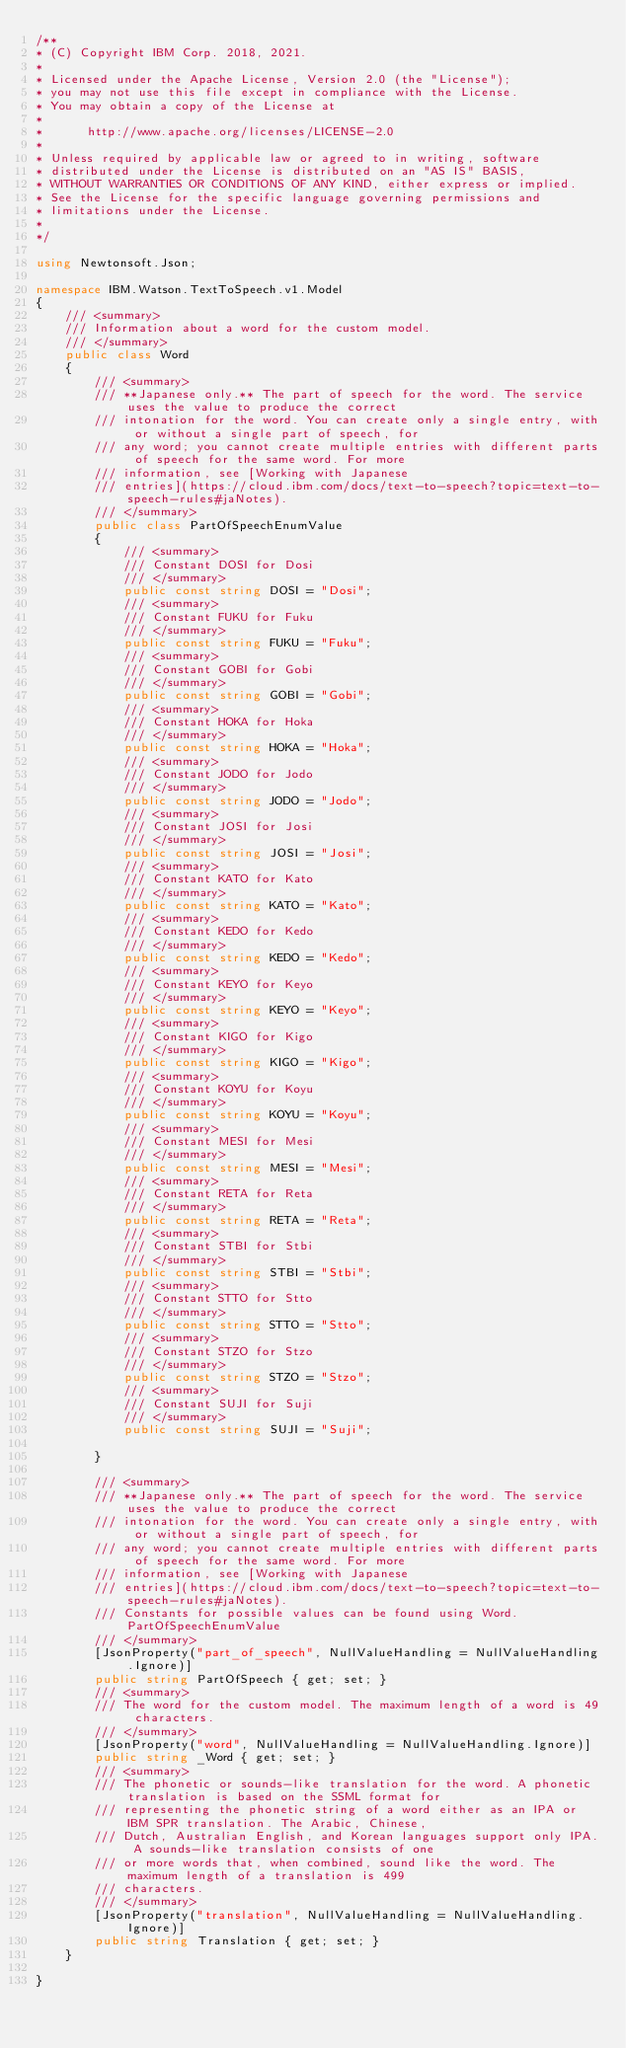<code> <loc_0><loc_0><loc_500><loc_500><_C#_>/**
* (C) Copyright IBM Corp. 2018, 2021.
*
* Licensed under the Apache License, Version 2.0 (the "License");
* you may not use this file except in compliance with the License.
* You may obtain a copy of the License at
*
*      http://www.apache.org/licenses/LICENSE-2.0
*
* Unless required by applicable law or agreed to in writing, software
* distributed under the License is distributed on an "AS IS" BASIS,
* WITHOUT WARRANTIES OR CONDITIONS OF ANY KIND, either express or implied.
* See the License for the specific language governing permissions and
* limitations under the License.
*
*/

using Newtonsoft.Json;

namespace IBM.Watson.TextToSpeech.v1.Model
{
    /// <summary>
    /// Information about a word for the custom model.
    /// </summary>
    public class Word
    {
        /// <summary>
        /// **Japanese only.** The part of speech for the word. The service uses the value to produce the correct
        /// intonation for the word. You can create only a single entry, with or without a single part of speech, for
        /// any word; you cannot create multiple entries with different parts of speech for the same word. For more
        /// information, see [Working with Japanese
        /// entries](https://cloud.ibm.com/docs/text-to-speech?topic=text-to-speech-rules#jaNotes).
        /// </summary>
        public class PartOfSpeechEnumValue
        {
            /// <summary>
            /// Constant DOSI for Dosi
            /// </summary>
            public const string DOSI = "Dosi";
            /// <summary>
            /// Constant FUKU for Fuku
            /// </summary>
            public const string FUKU = "Fuku";
            /// <summary>
            /// Constant GOBI for Gobi
            /// </summary>
            public const string GOBI = "Gobi";
            /// <summary>
            /// Constant HOKA for Hoka
            /// </summary>
            public const string HOKA = "Hoka";
            /// <summary>
            /// Constant JODO for Jodo
            /// </summary>
            public const string JODO = "Jodo";
            /// <summary>
            /// Constant JOSI for Josi
            /// </summary>
            public const string JOSI = "Josi";
            /// <summary>
            /// Constant KATO for Kato
            /// </summary>
            public const string KATO = "Kato";
            /// <summary>
            /// Constant KEDO for Kedo
            /// </summary>
            public const string KEDO = "Kedo";
            /// <summary>
            /// Constant KEYO for Keyo
            /// </summary>
            public const string KEYO = "Keyo";
            /// <summary>
            /// Constant KIGO for Kigo
            /// </summary>
            public const string KIGO = "Kigo";
            /// <summary>
            /// Constant KOYU for Koyu
            /// </summary>
            public const string KOYU = "Koyu";
            /// <summary>
            /// Constant MESI for Mesi
            /// </summary>
            public const string MESI = "Mesi";
            /// <summary>
            /// Constant RETA for Reta
            /// </summary>
            public const string RETA = "Reta";
            /// <summary>
            /// Constant STBI for Stbi
            /// </summary>
            public const string STBI = "Stbi";
            /// <summary>
            /// Constant STTO for Stto
            /// </summary>
            public const string STTO = "Stto";
            /// <summary>
            /// Constant STZO for Stzo
            /// </summary>
            public const string STZO = "Stzo";
            /// <summary>
            /// Constant SUJI for Suji
            /// </summary>
            public const string SUJI = "Suji";
            
        }

        /// <summary>
        /// **Japanese only.** The part of speech for the word. The service uses the value to produce the correct
        /// intonation for the word. You can create only a single entry, with or without a single part of speech, for
        /// any word; you cannot create multiple entries with different parts of speech for the same word. For more
        /// information, see [Working with Japanese
        /// entries](https://cloud.ibm.com/docs/text-to-speech?topic=text-to-speech-rules#jaNotes).
        /// Constants for possible values can be found using Word.PartOfSpeechEnumValue
        /// </summary>
        [JsonProperty("part_of_speech", NullValueHandling = NullValueHandling.Ignore)]
        public string PartOfSpeech { get; set; }
        /// <summary>
        /// The word for the custom model. The maximum length of a word is 49 characters.
        /// </summary>
        [JsonProperty("word", NullValueHandling = NullValueHandling.Ignore)]
        public string _Word { get; set; }
        /// <summary>
        /// The phonetic or sounds-like translation for the word. A phonetic translation is based on the SSML format for
        /// representing the phonetic string of a word either as an IPA or IBM SPR translation. The Arabic, Chinese,
        /// Dutch, Australian English, and Korean languages support only IPA. A sounds-like translation consists of one
        /// or more words that, when combined, sound like the word. The maximum length of a translation is 499
        /// characters.
        /// </summary>
        [JsonProperty("translation", NullValueHandling = NullValueHandling.Ignore)]
        public string Translation { get; set; }
    }

}
</code> 